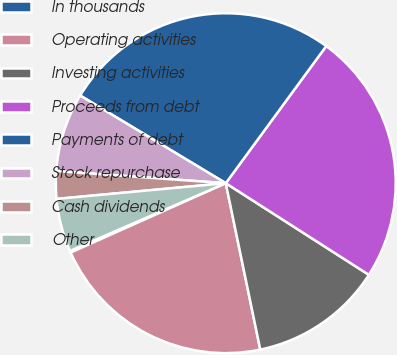<chart> <loc_0><loc_0><loc_500><loc_500><pie_chart><fcel>In thousands<fcel>Operating activities<fcel>Investing activities<fcel>Proceeds from debt<fcel>Payments of debt<fcel>Stock repurchase<fcel>Cash dividends<fcel>Other<nl><fcel>0.17%<fcel>21.56%<fcel>12.68%<fcel>24.0%<fcel>26.44%<fcel>7.49%<fcel>2.61%<fcel>5.05%<nl></chart> 